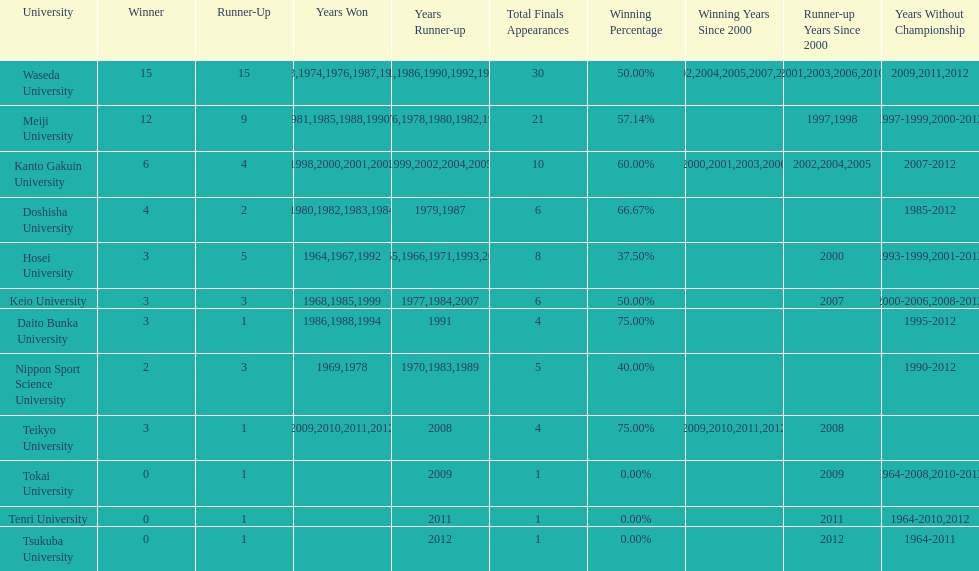Who won the last championship recorded on this table? Teikyo University. 